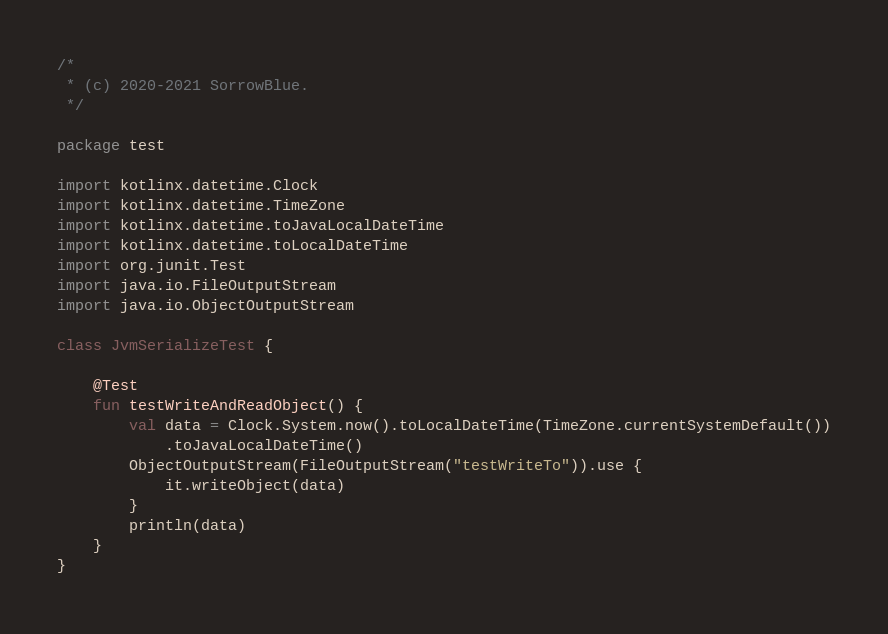Convert code to text. <code><loc_0><loc_0><loc_500><loc_500><_Kotlin_>/*
 * (c) 2020-2021 SorrowBlue.
 */

package test

import kotlinx.datetime.Clock
import kotlinx.datetime.TimeZone
import kotlinx.datetime.toJavaLocalDateTime
import kotlinx.datetime.toLocalDateTime
import org.junit.Test
import java.io.FileOutputStream
import java.io.ObjectOutputStream

class JvmSerializeTest {

    @Test
    fun testWriteAndReadObject() {
        val data = Clock.System.now().toLocalDateTime(TimeZone.currentSystemDefault())
            .toJavaLocalDateTime()
        ObjectOutputStream(FileOutputStream("testWriteTo")).use {
            it.writeObject(data)
        }
        println(data)
    }
}
</code> 